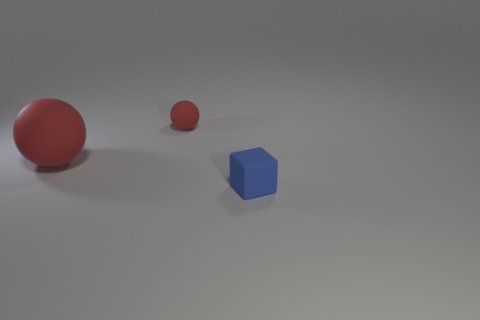Add 2 small red spheres. How many objects exist? 5 Subtract all blocks. How many objects are left? 2 Add 3 big matte balls. How many big matte balls exist? 4 Subtract 0 purple blocks. How many objects are left? 3 Subtract all big purple rubber spheres. Subtract all small blue blocks. How many objects are left? 2 Add 1 small blue matte cubes. How many small blue matte cubes are left? 2 